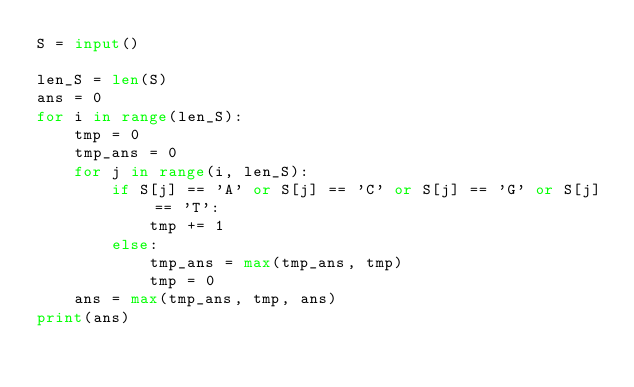<code> <loc_0><loc_0><loc_500><loc_500><_Python_>S = input()

len_S = len(S)
ans = 0
for i in range(len_S):
    tmp = 0
    tmp_ans = 0
    for j in range(i, len_S):
        if S[j] == 'A' or S[j] == 'C' or S[j] == 'G' or S[j] == 'T':
            tmp += 1
        else:
            tmp_ans = max(tmp_ans, tmp)
            tmp = 0
    ans = max(tmp_ans, tmp, ans)
print(ans)</code> 